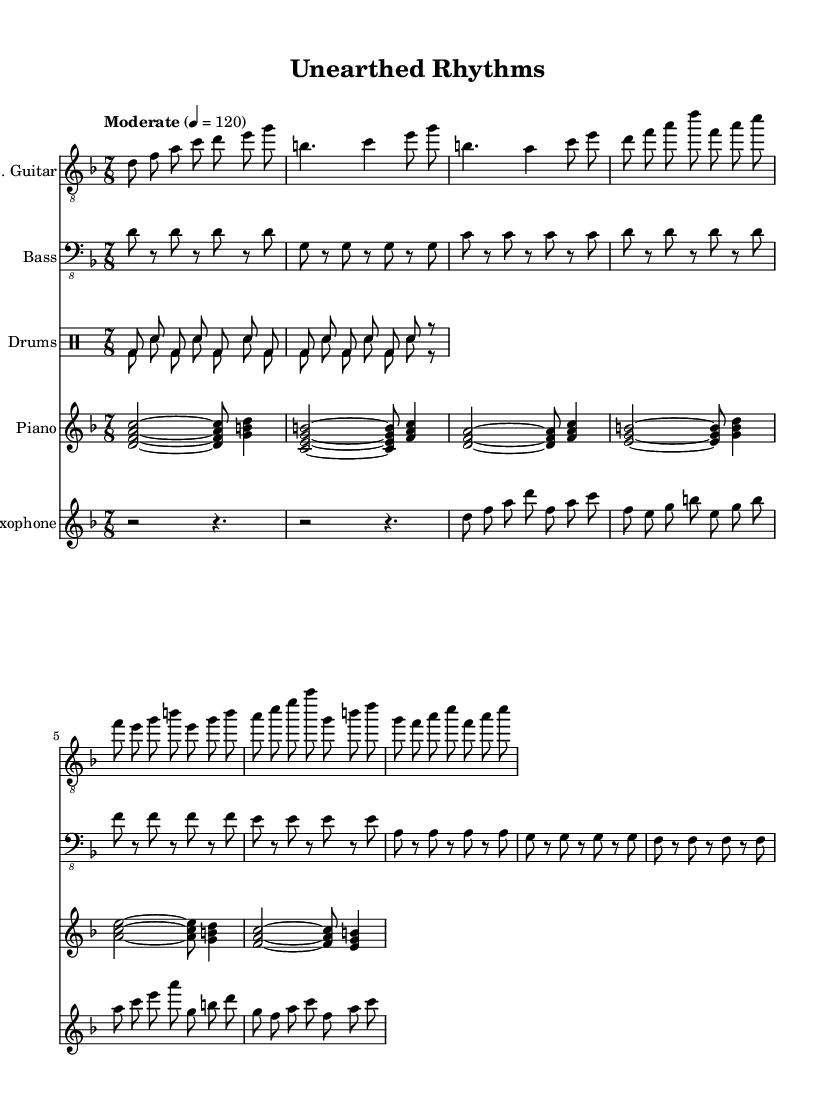What is the time signature of this music? The time signature is represented at the beginning of the score with the notation 7/8, indicating seven beats per measure with each beat being an eighth note.
Answer: 7/8 What key is this piece written in? The key signature is indicated by the notation at the beginning, showing two flats (B-flat and E-flat), which corresponds to D minor.
Answer: D minor What is the tempo marking given in the score? The tempo marking appears at the beginning of the score indicating a moderate pace of 120 beats per minute.
Answer: Moderate 4 = 120 How many instruments are featured in this score? By counting the different instrument sections indicated in the score, there are five distinct instruments: electric guitar, bass, drums, piano, and saxophone.
Answer: Five What section of the music has the most distinct rhythmic pattern? The drumming section features a repeated rhythmic pattern, specifically in the drums up and drums down lines, providing a unique fusion of rhythm integral to the genre's feel.
Answer: Drums What type of fusion is represented in this music? The title and combined genres represented in the instruments, along with the improvisational styles typical of jazz-rock, indicate it is a fusion of jazz and rock music.
Answer: Jazz-rock fusion Which instrument plays the introductory melody? The electric guitar plays the introductory melody, as indicated by the section labeled 'Intro' and the notes written specifically for that instrument.
Answer: Electric guitar 